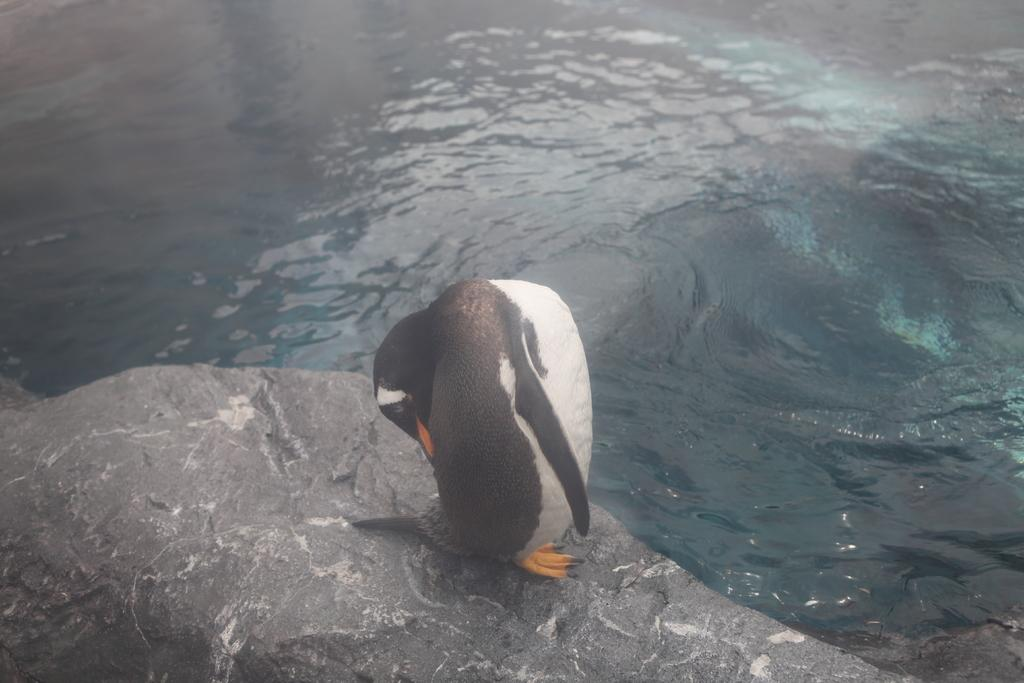What type of animal is in the image? There is a bird in the image. Where is the bird located? The bird is on a stone. What else can be seen in the image besides the bird? There is water visible in the image. How many trees are surrounding the bear in the image? There is no bear present in the image, and therefore no trees surrounding it. 